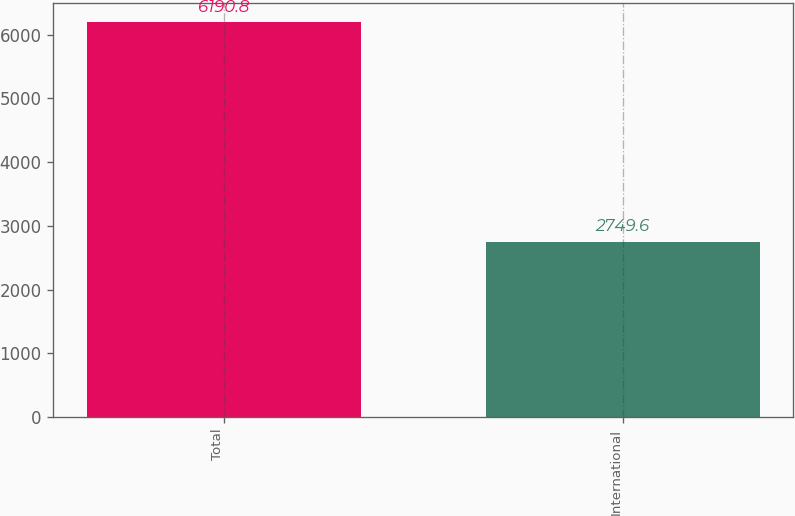Convert chart. <chart><loc_0><loc_0><loc_500><loc_500><bar_chart><fcel>Total<fcel>International<nl><fcel>6190.8<fcel>2749.6<nl></chart> 